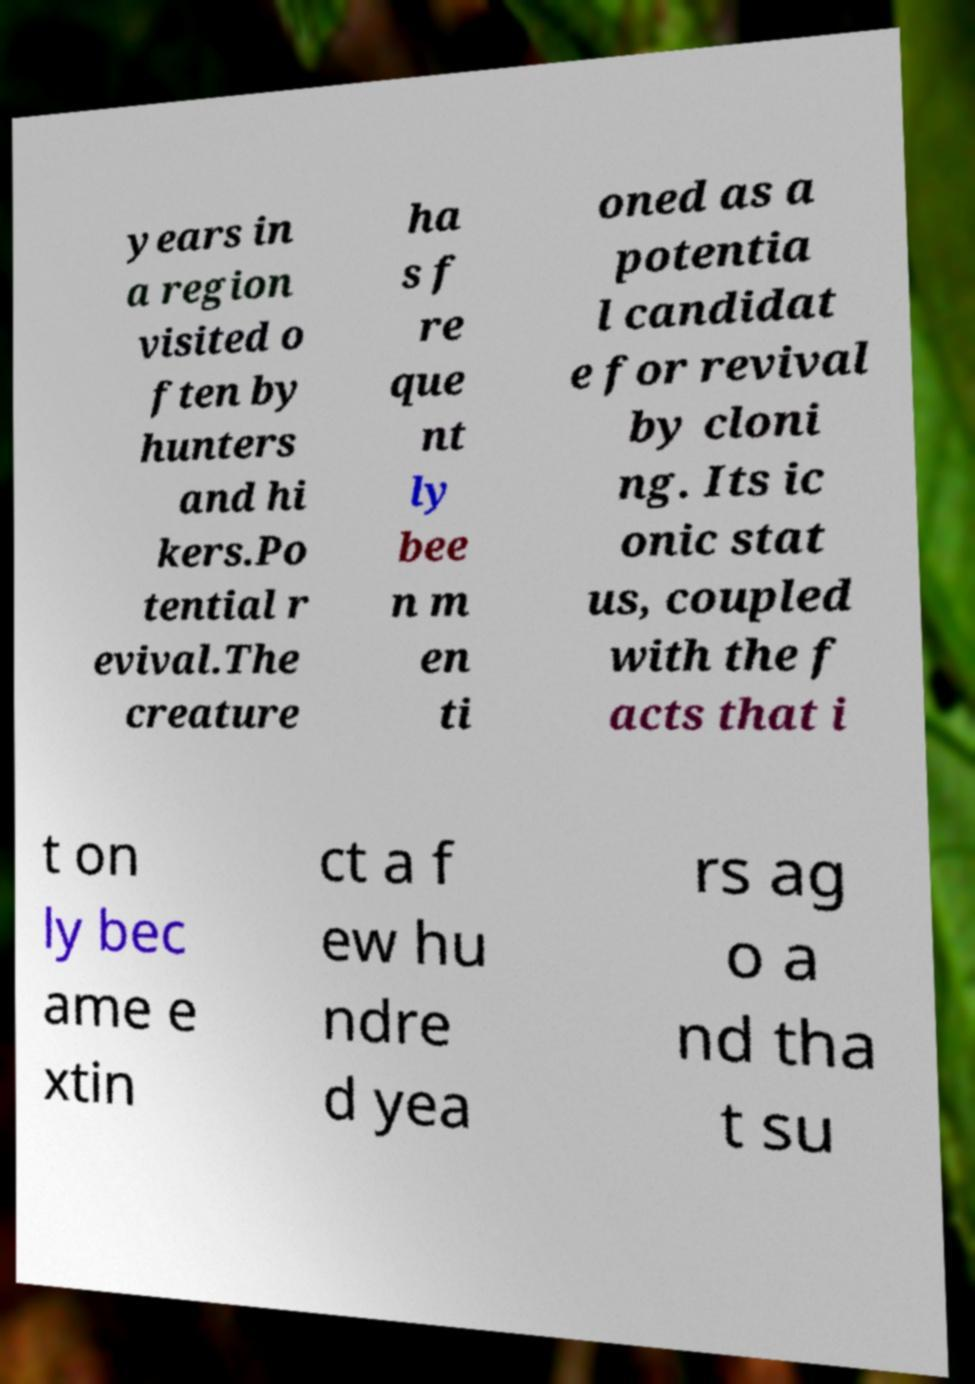I need the written content from this picture converted into text. Can you do that? years in a region visited o ften by hunters and hi kers.Po tential r evival.The creature ha s f re que nt ly bee n m en ti oned as a potentia l candidat e for revival by cloni ng. Its ic onic stat us, coupled with the f acts that i t on ly bec ame e xtin ct a f ew hu ndre d yea rs ag o a nd tha t su 